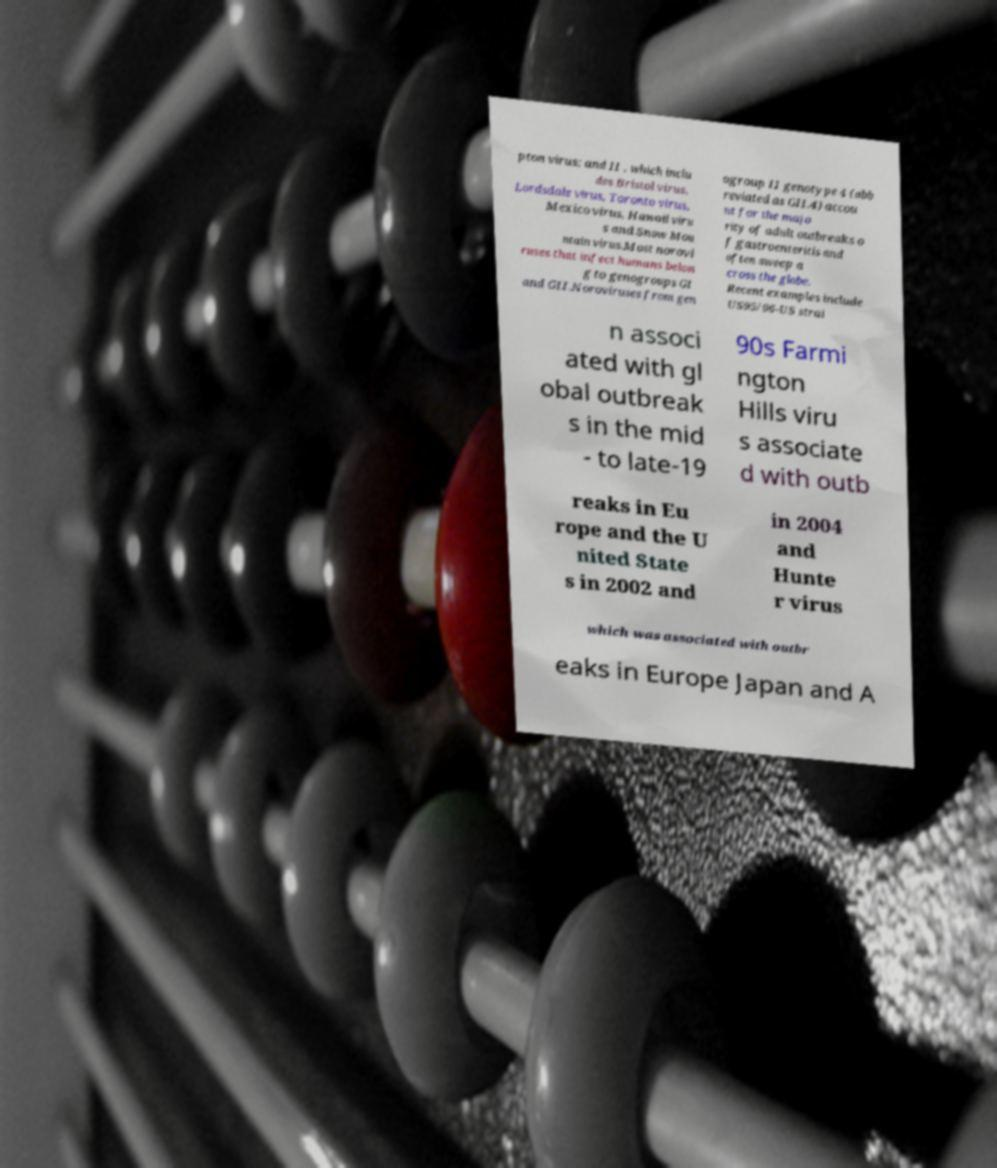Please identify and transcribe the text found in this image. pton virus; and II , which inclu des Bristol virus, Lordsdale virus, Toronto virus, Mexico virus, Hawaii viru s and Snow Mou ntain virus.Most norovi ruses that infect humans belon g to genogroups GI and GII.Noroviruses from gen ogroup II genotype 4 (abb reviated as GII.4) accou nt for the majo rity of adult outbreaks o f gastroenteritis and often sweep a cross the globe. Recent examples include US95/96-US strai n associ ated with gl obal outbreak s in the mid - to late-19 90s Farmi ngton Hills viru s associate d with outb reaks in Eu rope and the U nited State s in 2002 and in 2004 and Hunte r virus which was associated with outbr eaks in Europe Japan and A 